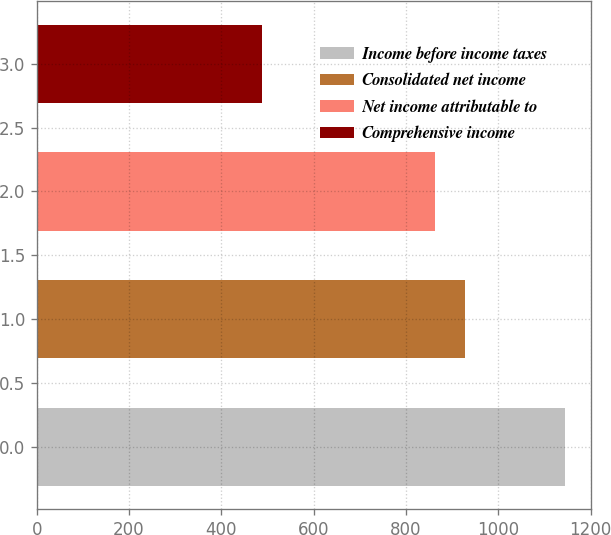<chart> <loc_0><loc_0><loc_500><loc_500><bar_chart><fcel>Income before income taxes<fcel>Consolidated net income<fcel>Net income attributable to<fcel>Comprehensive income<nl><fcel>1144.7<fcel>928.47<fcel>862.9<fcel>489<nl></chart> 